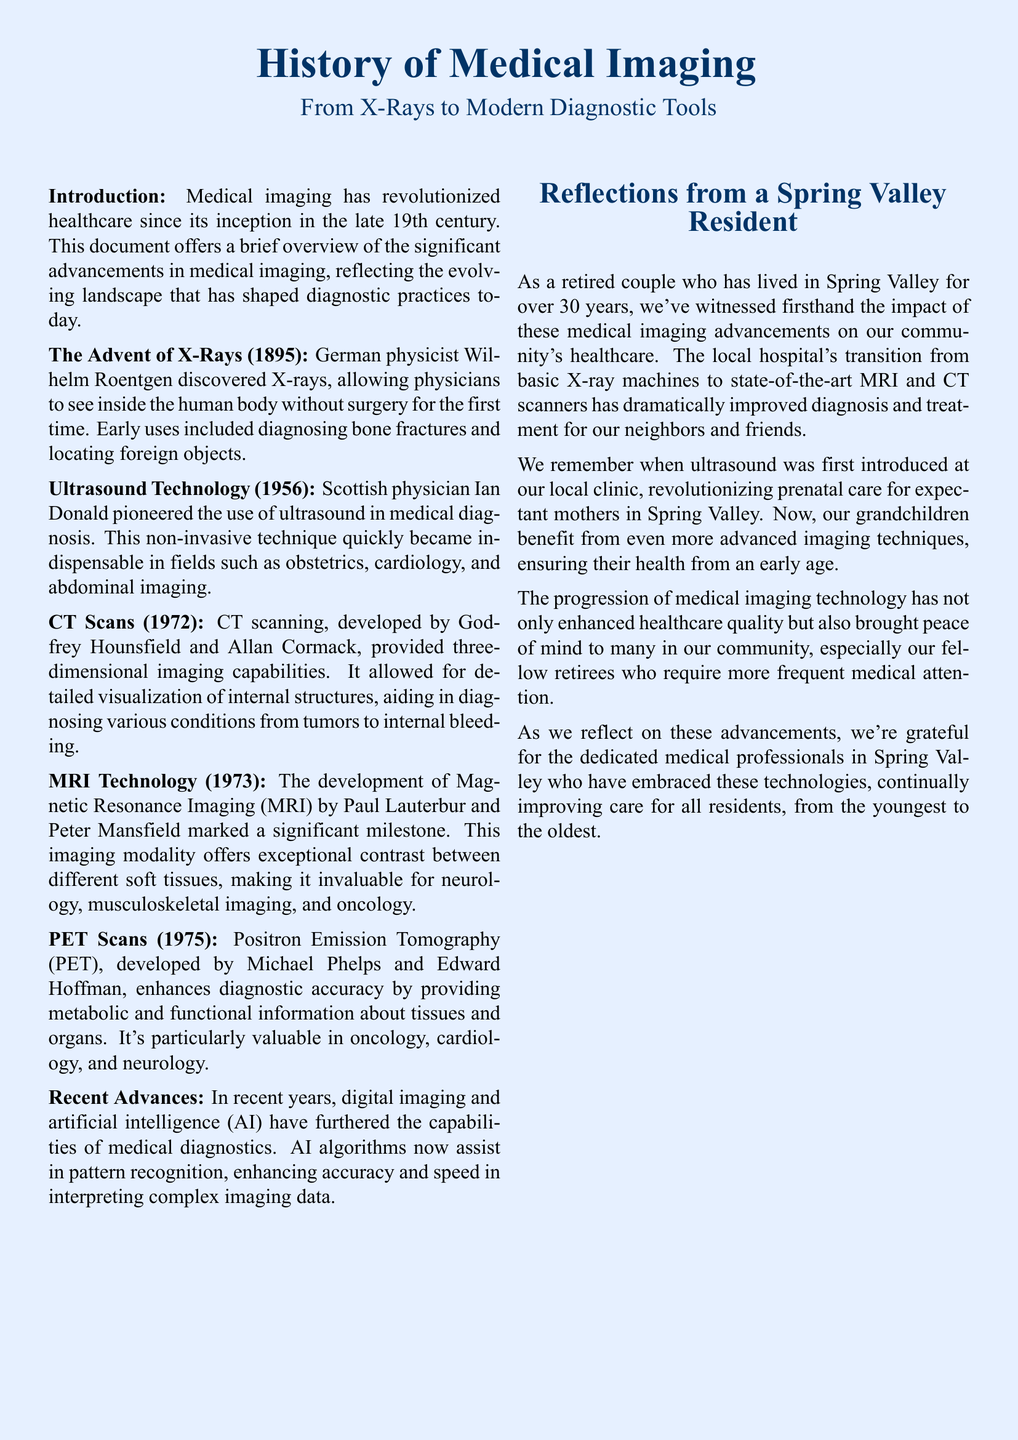What year was X-ray technology discovered? The document states that X-rays were discovered in 1895.
Answer: 1895 Who pioneered the use of ultrasound in medical diagnosis? The document mentions that Scottish physician Ian Donald pioneered the use of ultrasound.
Answer: Ian Donald What key imaging technology was developed in 1972? The document indicates that CT scans were developed in 1972.
Answer: CT scans Which imaging modality is known for exceptional contrast between soft tissues? The document specifies that MRI technology offers exceptional contrast between different soft tissues.
Answer: MRI What is the primary benefit of recent advances in medical diagnostics mentioned? The document highlights that AI algorithms enhance accuracy and speed in interpreting imaging data.
Answer: AI algorithms How many years have the residents lived in Spring Valley? The document states that the retired couple has lived in Spring Valley for over 30 years.
Answer: over 30 years What significant change occurred in the local hospital regarding imaging technology? The document reflects that the transition from basic X-ray machines to state-of-the-art MRI and CT scanners has occurred.
Answer: state-of-the-art MRI and CT scanners What year was PET scanning developed? The document mentions that PET scans were developed in 1975.
Answer: 1975 What aspect of medical imaging has offered peace of mind to retirees in the community? The document suggests that the progression of medical imaging technology has enhanced healthcare quality and brought peace of mind.
Answer: enhanced healthcare quality 